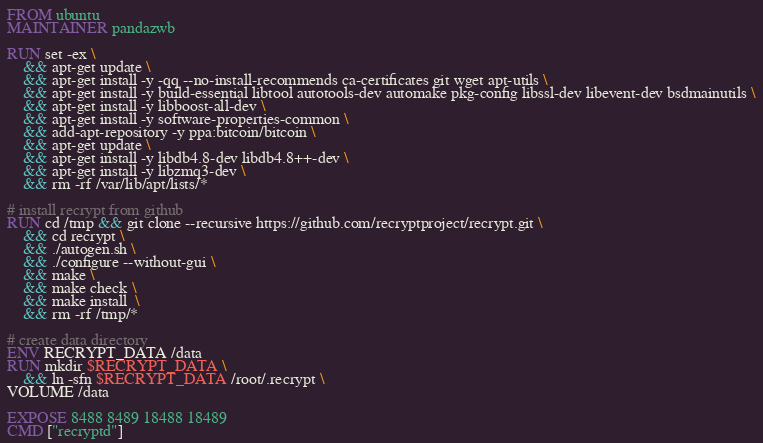Convert code to text. <code><loc_0><loc_0><loc_500><loc_500><_Dockerfile_>FROM ubuntu
MAINTAINER pandazwb

RUN set -ex \
    && apt-get update \
    && apt-get install -y -qq --no-install-recommends ca-certificates git wget apt-utils \
    && apt-get install -y build-essential libtool autotools-dev automake pkg-config libssl-dev libevent-dev bsdmainutils \
    && apt-get install -y libboost-all-dev \
	&& apt-get install -y software-properties-common \
	&& add-apt-repository -y ppa:bitcoin/bitcoin \
	&& apt-get update \
	&& apt-get install -y libdb4.8-dev libdb4.8++-dev \
	&& apt-get install -y libzmq3-dev \
 	&& rm -rf /var/lib/apt/lists/*

# install recrypt from github
RUN cd /tmp && git clone --recursive https://github.com/recryptproject/recrypt.git \
	&& cd recrypt \
	&& ./autogen.sh \
	&& ./configure --without-gui \
	&& make \
	&& make check \
	&& make install  \
	&& rm -rf /tmp/*

# create data directory
ENV RECRYPT_DATA /data
RUN mkdir $RECRYPT_DATA \
	&& ln -sfn $RECRYPT_DATA /root/.recrypt \
VOLUME /data

EXPOSE 8488 8489 18488 18489
CMD ["recryptd"]
</code> 